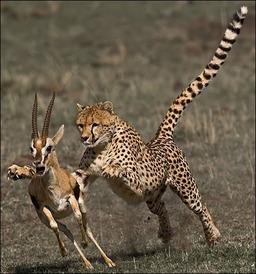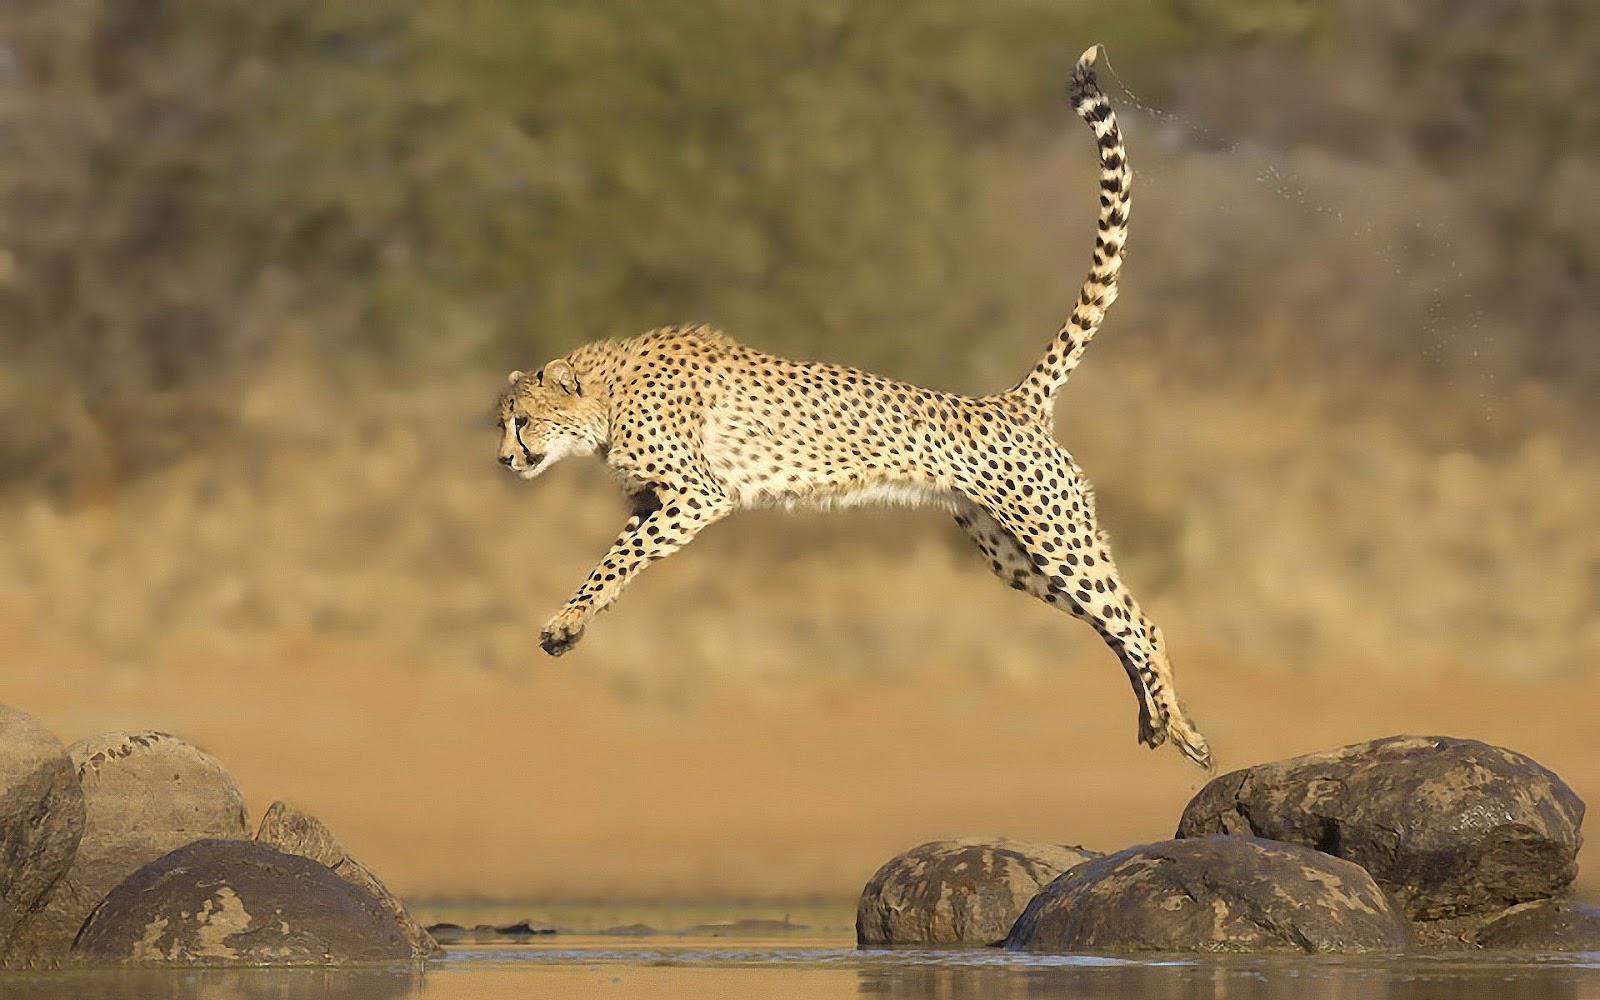The first image is the image on the left, the second image is the image on the right. Considering the images on both sides, is "There are exactly three animals in the image on the right." valid? Answer yes or no. No. The first image is the image on the left, the second image is the image on the right. Assess this claim about the two images: "A wild cat with front paws extended is pouncing on visible prey in one image.". Correct or not? Answer yes or no. Yes. 